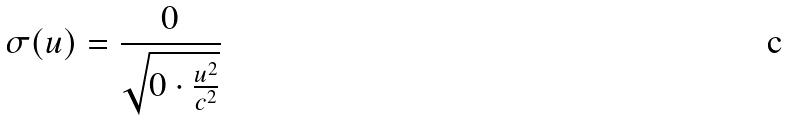<formula> <loc_0><loc_0><loc_500><loc_500>\sigma ( u ) = \frac { 0 } { \sqrt { 0 \cdot \frac { u ^ { 2 } } { c ^ { 2 } } } }</formula> 